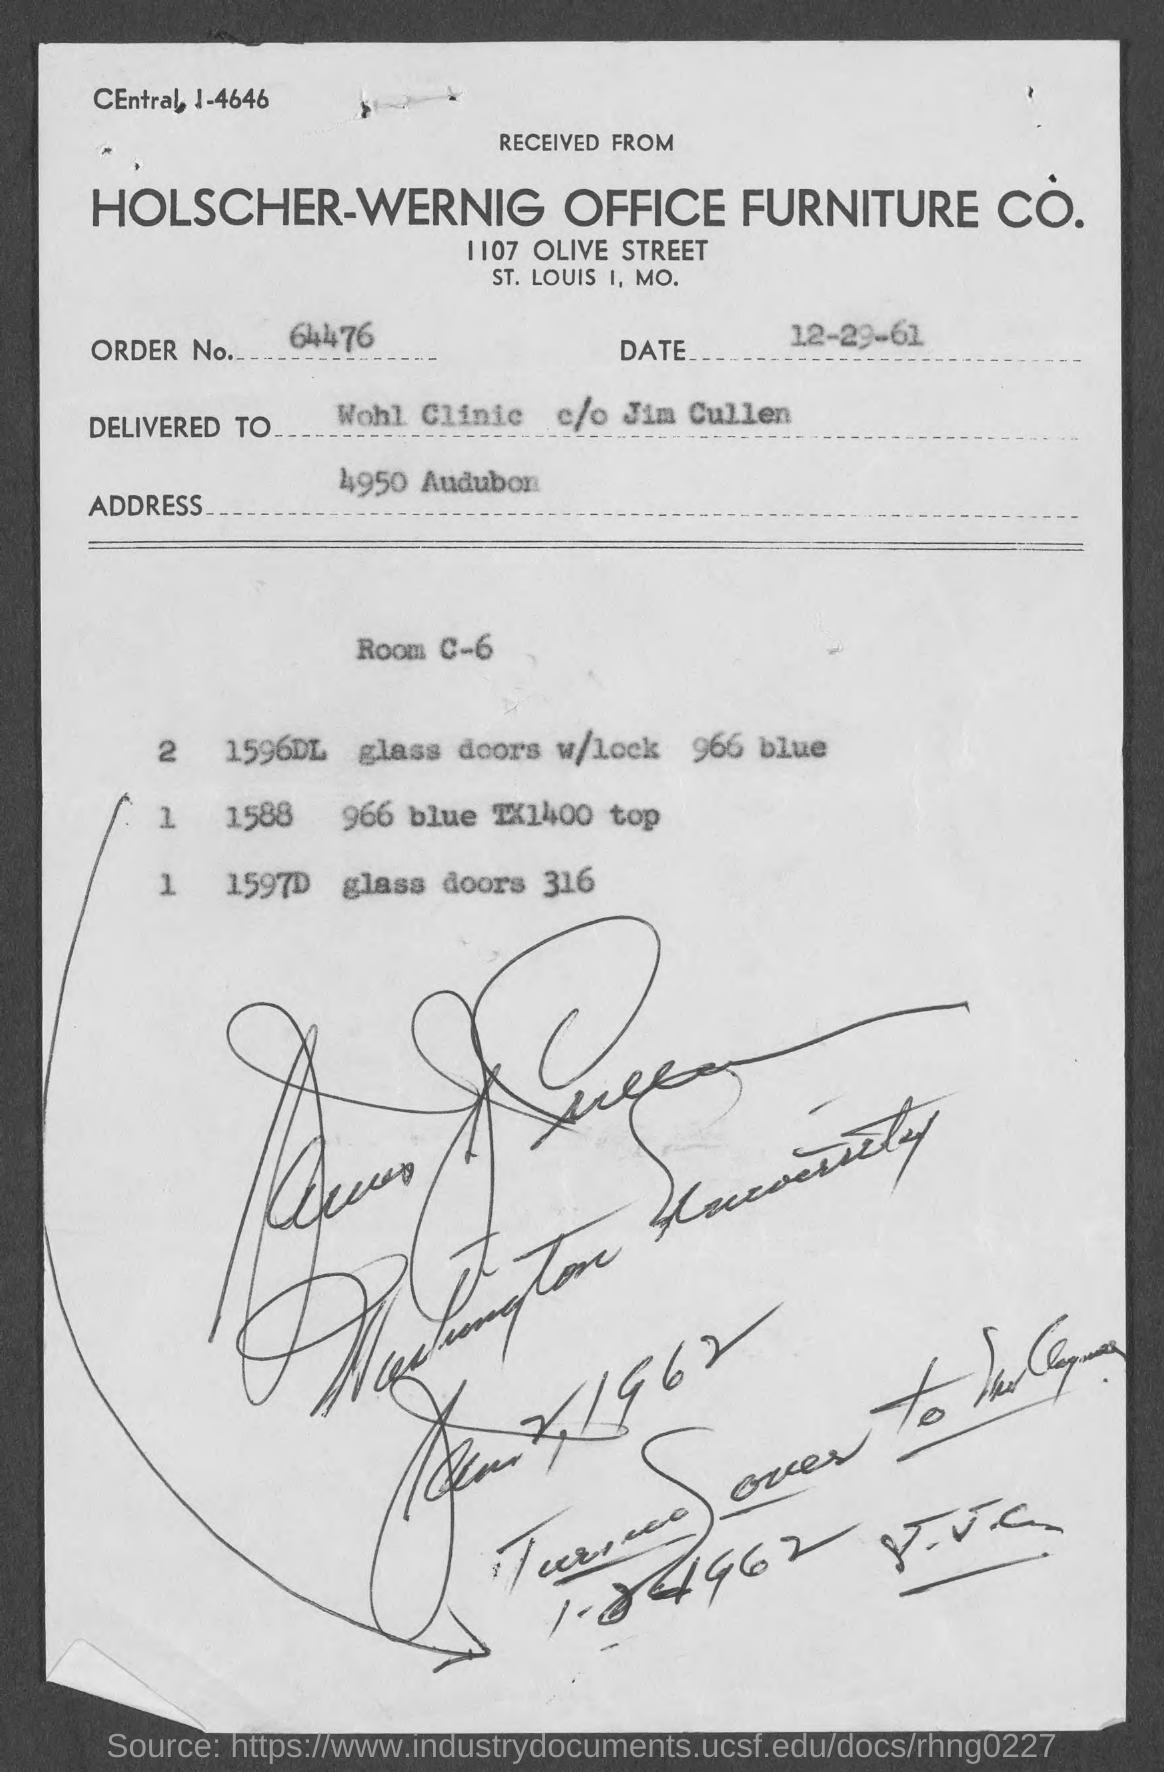Draw attention to some important aspects in this diagram. The order number is 64476... The address is 4950 Audubon. The date mentioned in the document is December 29, 1961. 